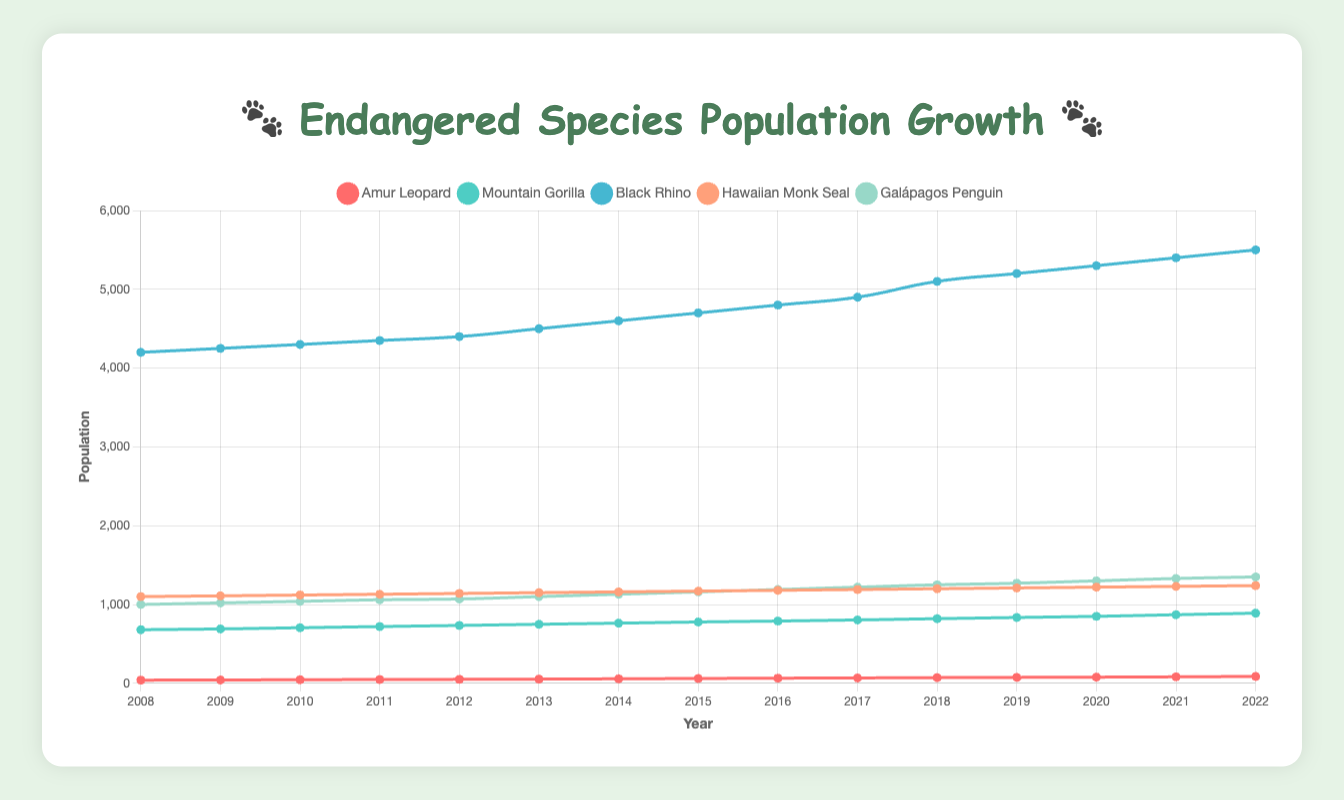Which species has the highest population growth over the 15-year period? To find the species with the highest population growth, subtract the initial population in 2008 from the final population in 2022 for each species. Amur Leopard: 87 - 40 = 47; Mountain Gorilla: 890 - 680 = 210; Black Rhino: 5500 - 4200 = 1300; Hawaiian Monk Seal: 1240 - 1100 = 140; Galápagos Penguin: 1350 - 1000 = 350. The Black Rhino has the highest population growth of 1300.
Answer: Black Rhino Which species' population surpassed 800 first? By examining the Mountain Gorilla population, the figures surpass 800 in the year 2020. Other species never surpass this threshold.
Answer: Mountain Gorilla How does the population growth of the Galápagos Penguin compare to the Hawaiian Monk Seal over the 15 years? Galápagos Penguin growth: 1350 - 1000 = 350. Hawaiian Monk Seal growth: 1240 - 1100 = 140. Thus, the Galápagos Penguin has a population growth of 350, while Hawaiian Monk Seal has 140 over the 15 years.
Answer: Galápagos Penguin has higher growth What is the difference in the population of the Mountain Gorilla and the Amur Leopard in 2022? Mountain Gorilla in 2022: 890, Amur Leopard in 2022: 87. Difference: 890 - 87 = 803.
Answer: 803 Did the population of any species decrease at any point during the 15 years? Observing the trendlines, none of the species show a decrease at any point from 2008 to 2022. All lines are ascending.
Answer: No In which year did the Black Rhino population reach 5000? Looking at the Black Rhino data, the population reaches 5000 in the year 2018.
Answer: 2018 Which species had the steadier population increase from 2008 to 2022? Both the Hawaiian Monk Seal and the Galápagos Penguin lines show relatively steady increases, but the Hawaiian Monk Seal has a more constant, linear ascent without drastic changes or fluctuations.
Answer: Hawaiian Monk Seal How many species had a population above 1000 in the year 2015? By referring to the 2015 populations: Amur Leopard 61, Mountain Gorilla 778, Black Rhino 4700, Hawaiian Monk Seal 1170, Galápagos Penguin 1160. There are 3 species above 1000: Mountain Gorilla, Black Rhino, and both seals.
Answer: 3 species What's the total population of all species combined in 2012? Summing up each species' population in 2012: Amur Leopard 50, Mountain Gorilla 734, Black Rhino 4400, Hawaiian Monk Seal 1140, Galápagos Penguin 1070; Total = 50 + 734 + 4400 + 1140 + 1070 = 7394.
Answer: 7394 